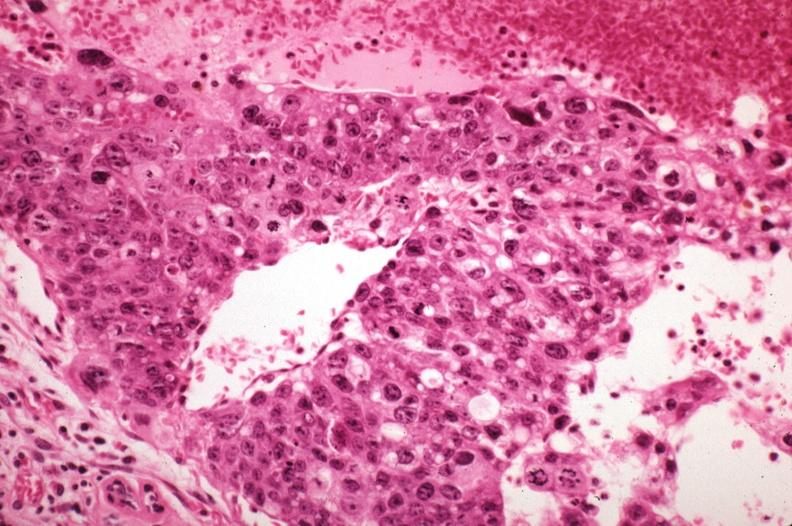s typical tuberculous exudate present?
Answer the question using a single word or phrase. No 